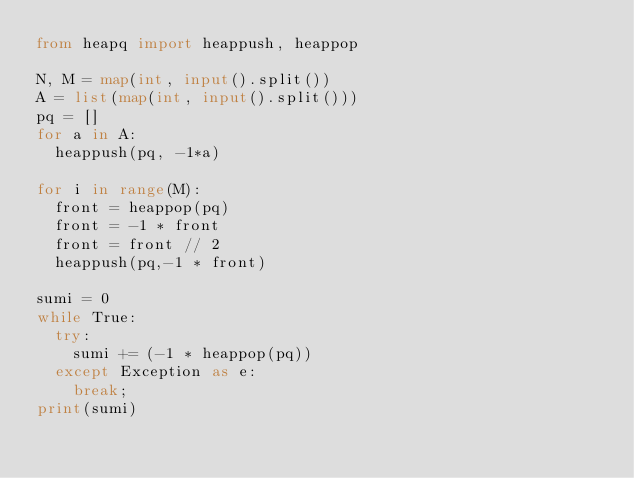<code> <loc_0><loc_0><loc_500><loc_500><_Python_>from heapq import heappush, heappop

N, M = map(int, input().split())
A = list(map(int, input().split()))
pq = []
for a in A:
	heappush(pq, -1*a)

for i in range(M):
	front = heappop(pq)
	front = -1 * front
	front = front // 2
	heappush(pq,-1 * front)

sumi = 0
while True:
	try:
		sumi += (-1 * heappop(pq))
	except Exception as e:
		break;
print(sumi)
	
</code> 